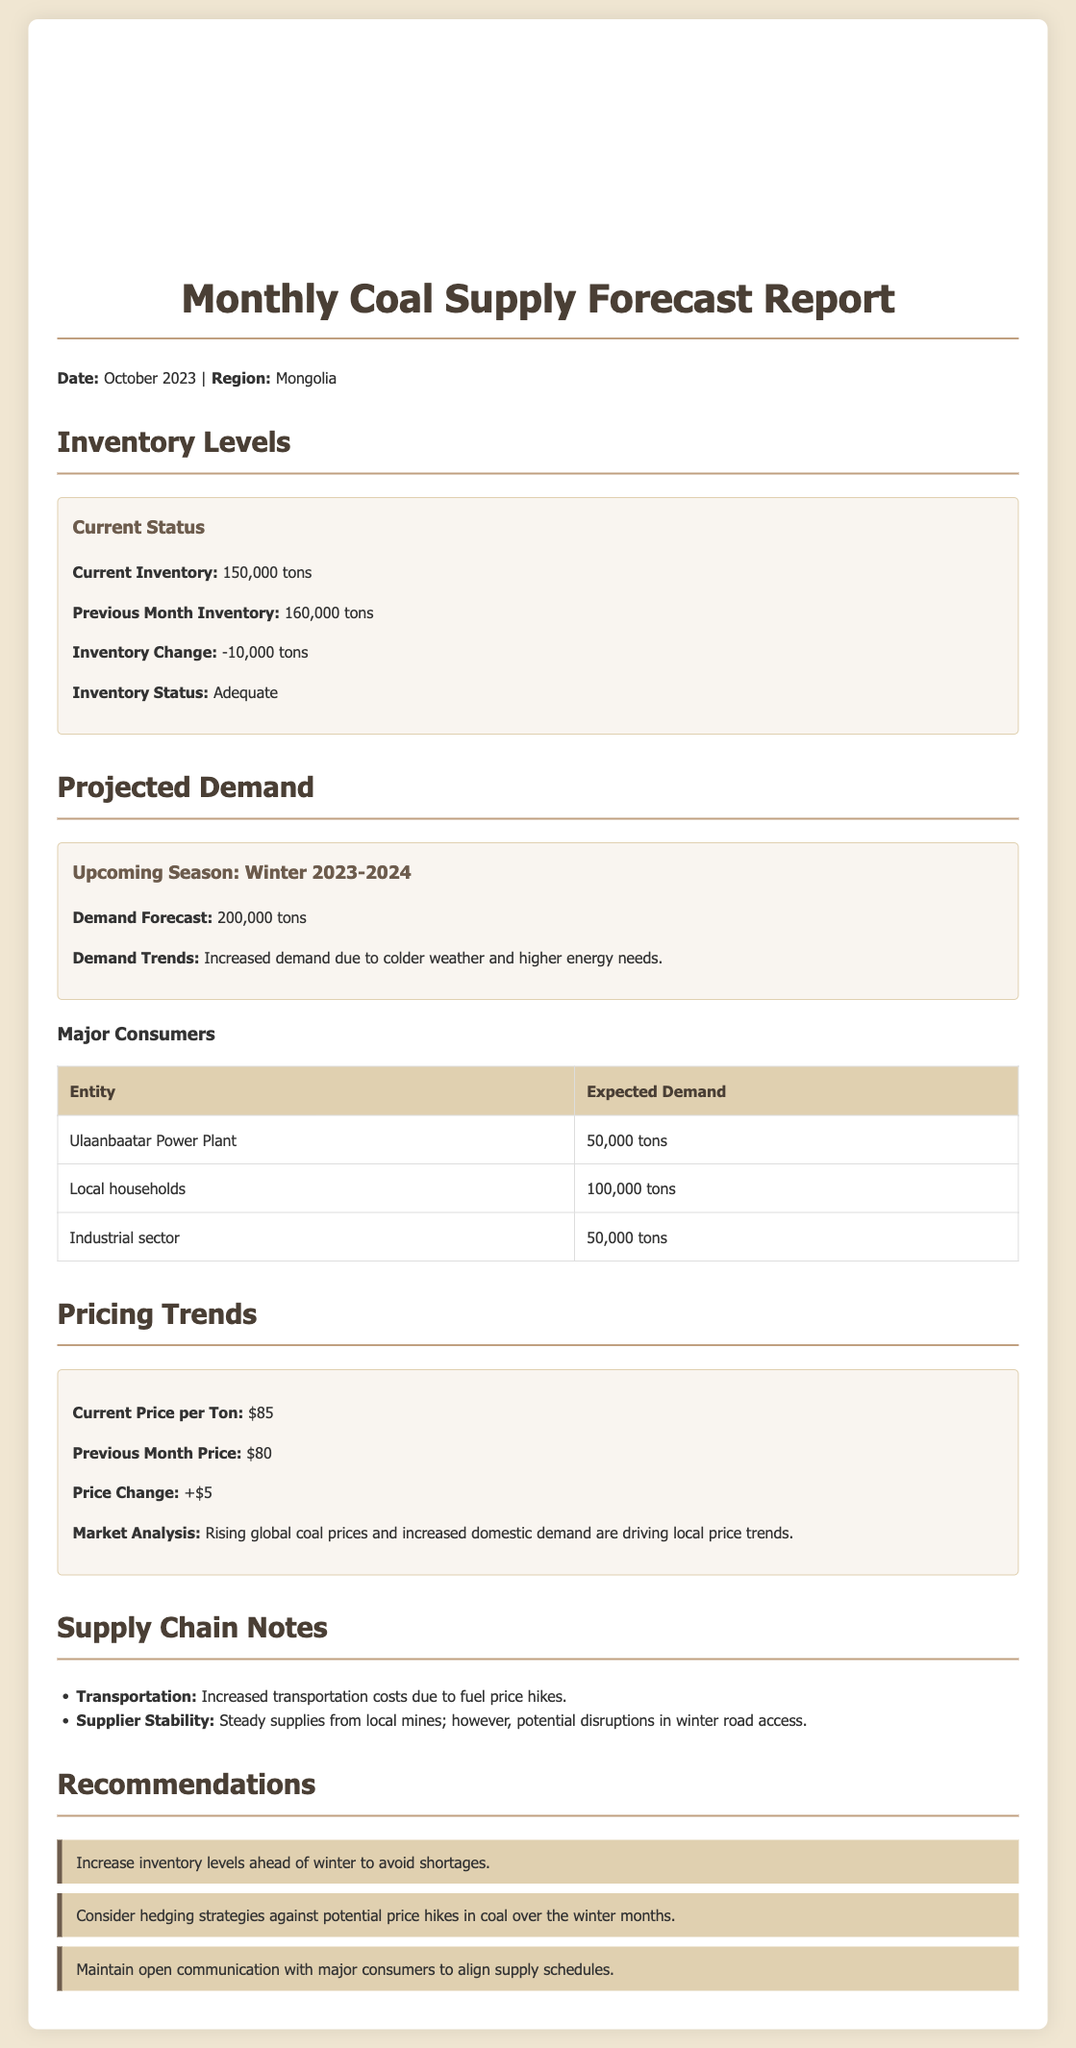What is the current inventory level? The current inventory level is stated in the document as 150,000 tons.
Answer: 150,000 tons What was the previous month's inventory level? The document provides the previous month's inventory level as 160,000 tons.
Answer: 160,000 tons What is the projected demand for the upcoming season? The demand forecast for Winter 2023-2024 is indicated as 200,000 tons.
Answer: 200,000 tons What is the current price per ton of coal? The document shows the current price per ton as $85.
Answer: $85 How much coal is expected to be demanded by local households? The expected demand from local households is listed as 100,000 tons.
Answer: 100,000 tons What change in inventory occurred from the previous month? The document notes an inventory change of -10,000 tons.
Answer: -10,000 tons What are the pricing trends based on market analysis? The market analysis states that rising global coal prices and increased domestic demand are driving local price trends.
Answer: Rising global coal prices What transportation-related issue is noted in the supply chain? The document highlights increased transportation costs due to fuel price hikes.
Answer: Increased transportation costs What is one of the recommendations for managing coal supply? One of the recommendations is to increase inventory levels ahead of winter to avoid shortages.
Answer: Increase inventory levels 